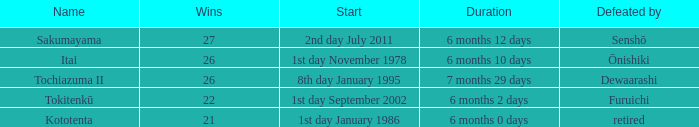What span was vanquished by retired? 6 months 0 days. 